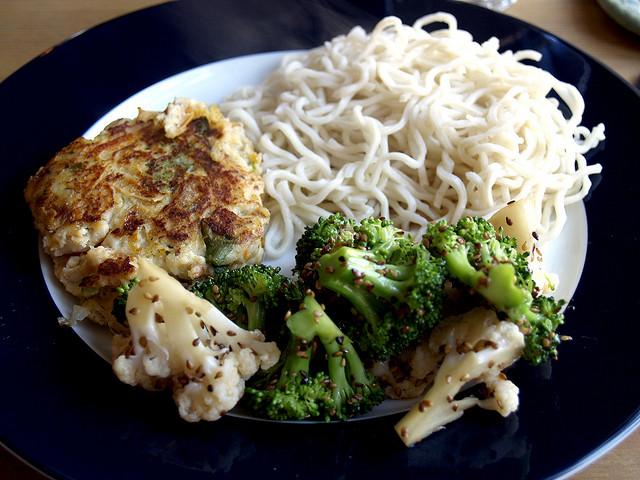Is there any dairy in this photo?
Short answer required. No. Is there cauliflower in the dish?
Be succinct. Yes. What kind of grain is on this plate?
Quick response, please. Noodles. What green vegetable is on the plate?
Give a very brief answer. Broccoli. Is this a typical American breakfast?
Be succinct. No. 